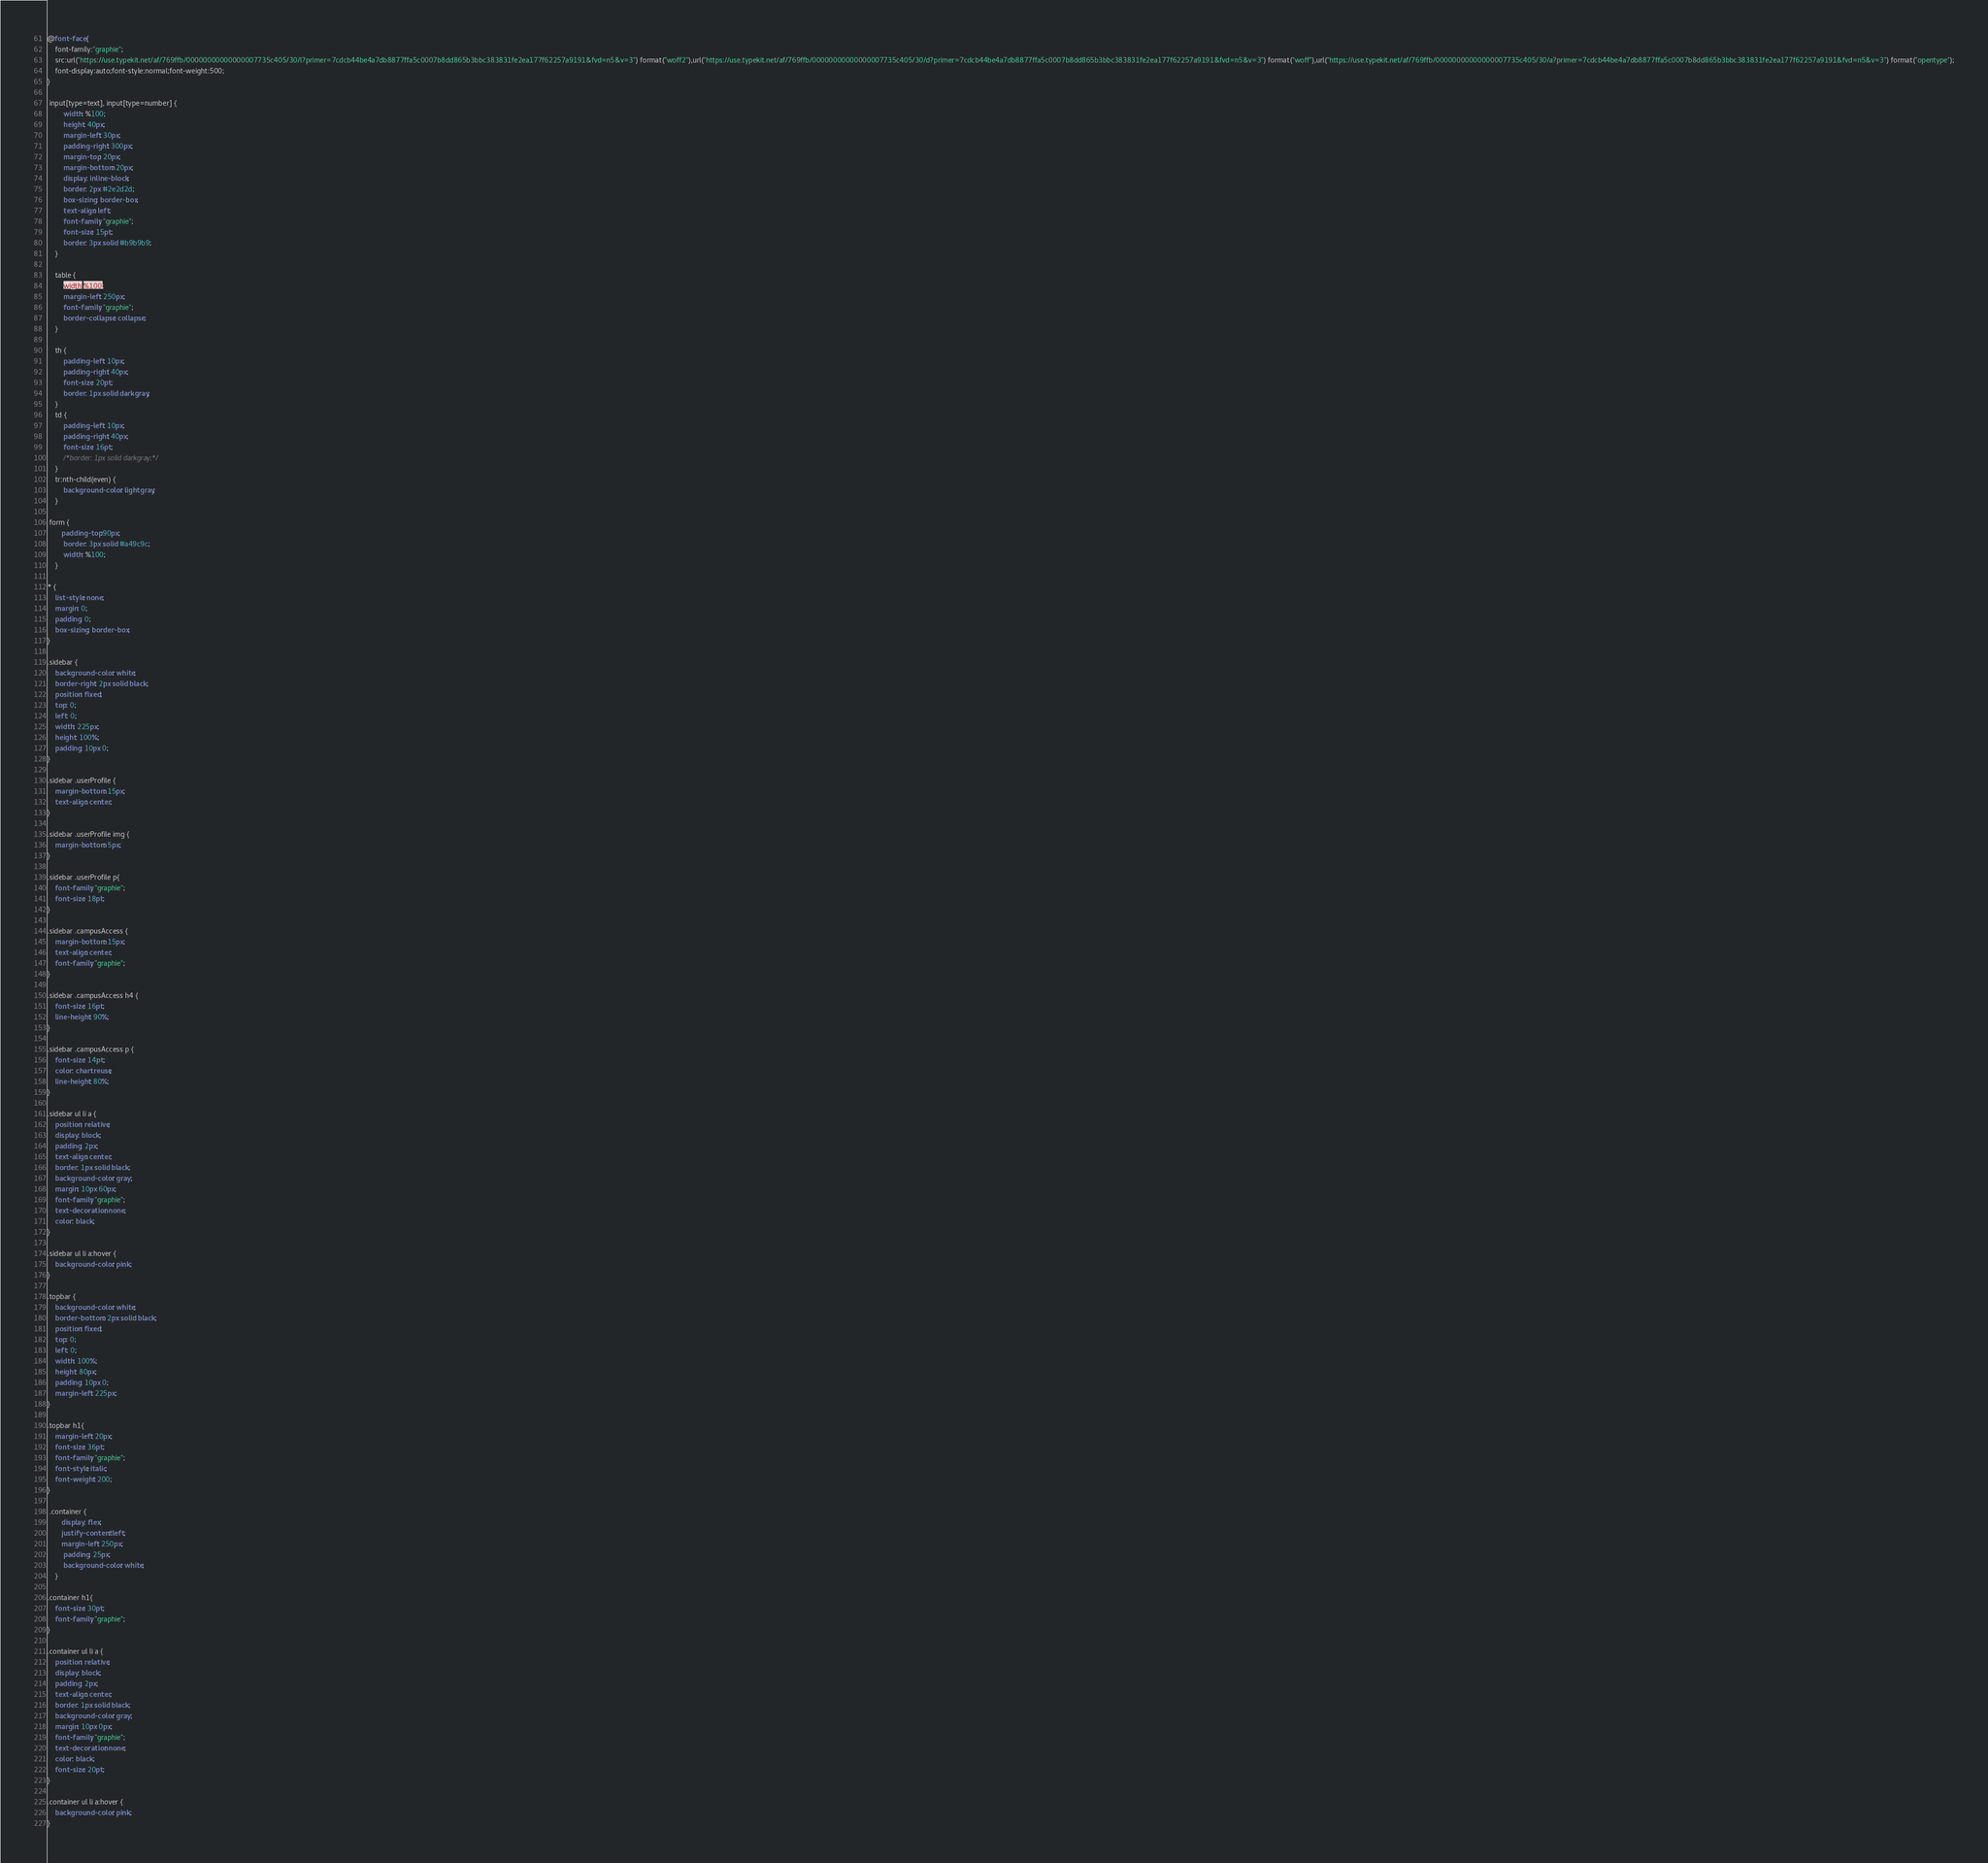Convert code to text. <code><loc_0><loc_0><loc_500><loc_500><_CSS_>@font-face {
    font-family:"graphie";
    src:url("https://use.typekit.net/af/769ffb/00000000000000007735c405/30/l?primer=7cdcb44be4a7db8877ffa5c0007b8dd865b3bbc383831fe2ea177f62257a9191&fvd=n5&v=3") format("woff2"),url("https://use.typekit.net/af/769ffb/00000000000000007735c405/30/d?primer=7cdcb44be4a7db8877ffa5c0007b8dd865b3bbc383831fe2ea177f62257a9191&fvd=n5&v=3") format("woff"),url("https://use.typekit.net/af/769ffb/00000000000000007735c405/30/a?primer=7cdcb44be4a7db8877ffa5c0007b8dd865b3bbc383831fe2ea177f62257a9191&fvd=n5&v=3") format("opentype");
    font-display:auto;font-style:normal;font-weight:500;
}

 input[type=text], input[type=number] {   
        width: %100;  
        height: 40px; 
        margin-left: 30px; 
        padding-right: 300px;       
        margin-top: 20px;
        margin-bottom: 20px;
        display: inline-block;   
        border: 2px #2e2d2d;   
        box-sizing: border-box;  
        text-align: left;
        font-family: "graphie";
        font-size: 15pt;
        border: 3px solid #b9b9b9;
    }  

    table {
        width %100;
        margin-left: 250px;
        font-family: "graphie";
        border-collapse: collapse;
    }

    th {
        padding-left: 10px;
        padding-right: 40px;
        font-size: 20pt;
        border: 1px solid darkgray;
    }
    td {
        padding-left: 10px;
        padding-right: 40px;
        font-size: 16pt;
        /*border: 1px solid darkgray;*/
    }
    tr:nth-child(even) {
        background-color: lightgray;
    }   

 form {   
       padding-top:90px;
        border: 3px solid #a49c9c;  
        width: %100;
    }   
    
* {
    list-style: none;
    margin: 0;
    padding: 0;
    box-sizing: border-box;
}

.sidebar {
    background-color: white;
    border-right: 2px solid black;
    position: fixed;
    top: 0;
    left: 0;
    width: 225px;
    height: 100%;
    padding: 10px 0;
}

.sidebar .userProfile {
    margin-bottom: 15px;
    text-align: center;
}

.sidebar .userProfile img {
    margin-bottom: 5px;
}

.sidebar .userProfile p{
    font-family: "graphie";
    font-size: 18pt;
}

.sidebar .campusAccess {
    margin-bottom: 15px;
    text-align: center;
    font-family: "graphie";
}

.sidebar .campusAccess h4 {
    font-size: 16pt;
    line-height: 90%;
}

.sidebar .campusAccess p {
    font-size: 14pt;
    color: chartreuse;
    line-height: 80%;
}

.sidebar ul li a {
    position: relative;
    display: block;
    padding: 2px;
    text-align: center;
    border: 1px solid black;
    background-color: gray;
    margin: 10px 60px;
    font-family: "graphie";
    text-decoration: none;
    color: black;
}

.sidebar ul li a:hover {
    background-color: pink;
}

.topbar {
    background-color: white;
    border-bottom: 2px solid black;
    position: fixed;
    top: 0;
    left: 0;
    width: 100%;
    height: 80px;
    padding: 10px 0;
    margin-left: 225px;
}

.topbar h1{
    margin-left: 20px;
    font-size: 36pt;
    font-family: "graphie";
    font-style: italic;
    font-weight: 200;
}

 .container {   
       display: flex;
       justify-content: left;
       margin-left: 250px;
        padding: 25px;   
        background-color: white;  
    }   

.container h1{
    font-size: 30pt;
    font-family: "graphie";
}

.container ul li a {
    position: relative;
    display: block;
    padding: 2px;
    text-align: center;
    border: 1px solid black;
    background-color: gray;
    margin: 10px 0px;
    font-family: "graphie";
    text-decoration: none;
    color: black;
    font-size: 20pt;
}

.container ul li a:hover {
    background-color: pink;
}
</code> 